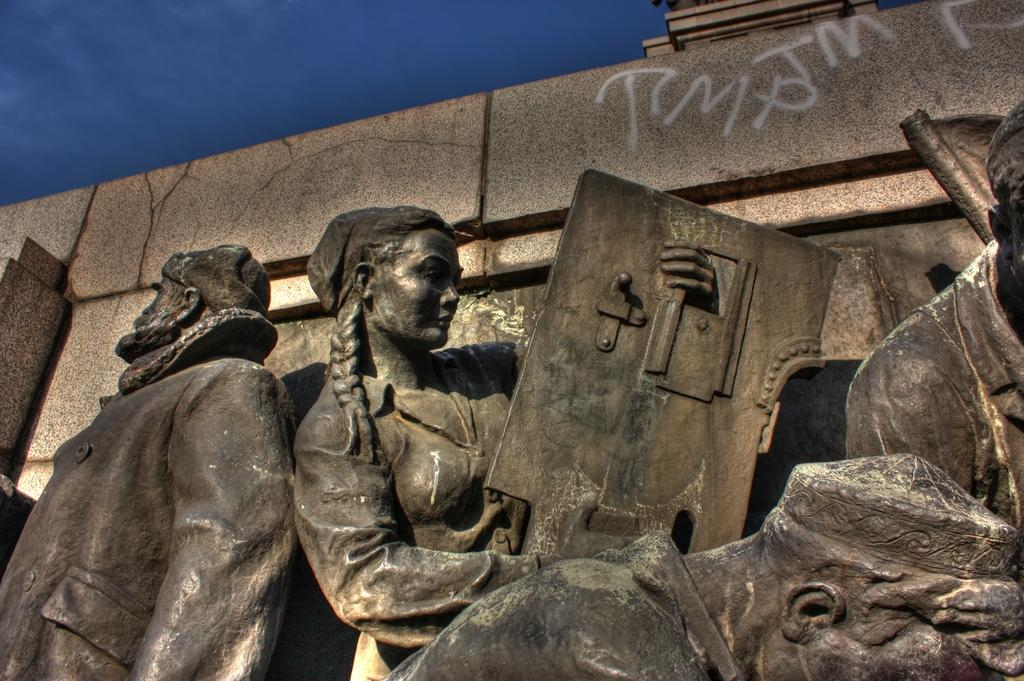What is the main subject of the image? There is a sculpture in the image. How many ladybugs are crawling on the sculpture in the image? There is no mention of ladybugs in the image, so we cannot determine their presence or quantity. 